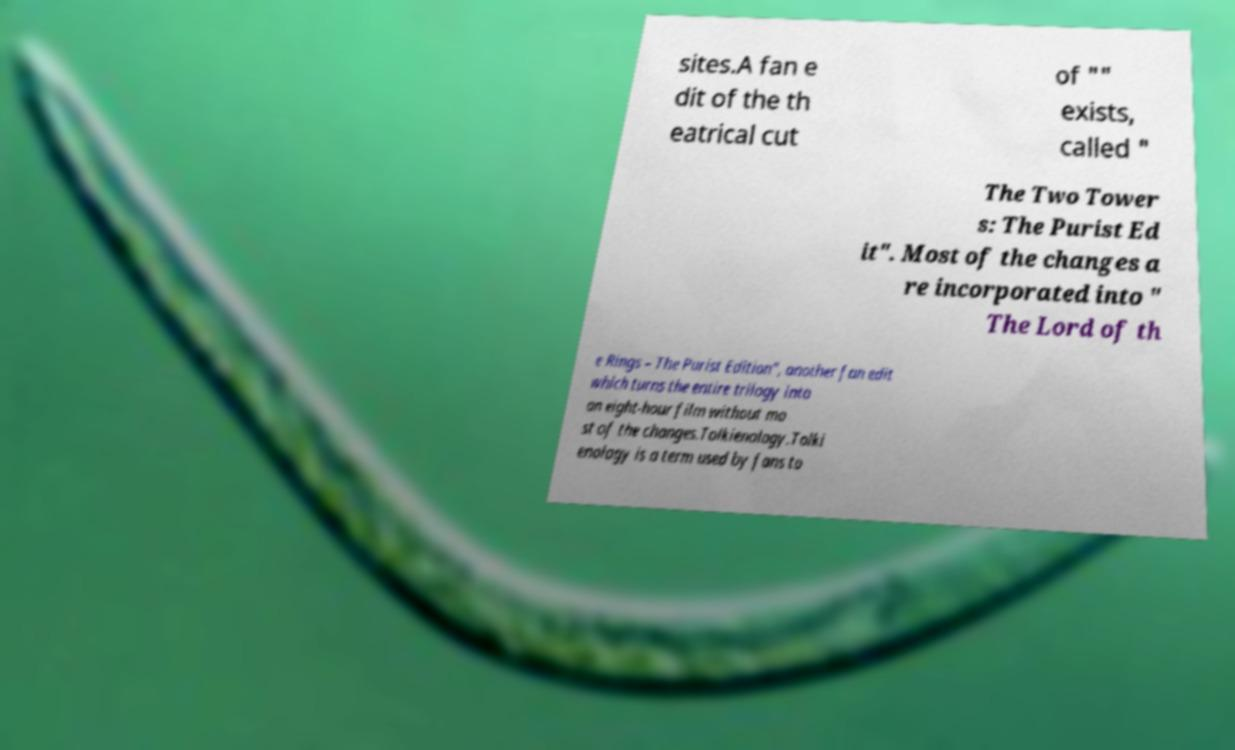Can you read and provide the text displayed in the image?This photo seems to have some interesting text. Can you extract and type it out for me? sites.A fan e dit of the th eatrical cut of "" exists, called " The Two Tower s: The Purist Ed it". Most of the changes a re incorporated into " The Lord of th e Rings – The Purist Edition", another fan edit which turns the entire trilogy into an eight-hour film without mo st of the changes.Tolkienology.Tolki enology is a term used by fans to 